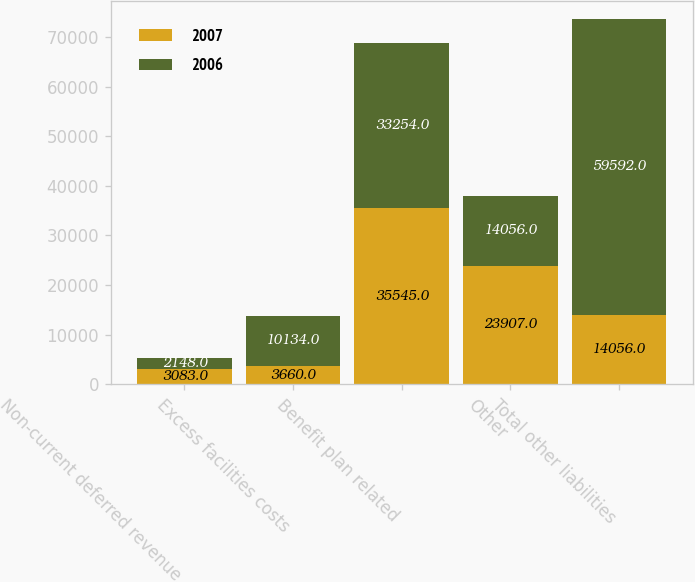Convert chart to OTSL. <chart><loc_0><loc_0><loc_500><loc_500><stacked_bar_chart><ecel><fcel>Non-current deferred revenue<fcel>Excess facilities costs<fcel>Benefit plan related<fcel>Other<fcel>Total other liabilities<nl><fcel>2007<fcel>3083<fcel>3660<fcel>35545<fcel>23907<fcel>14056<nl><fcel>2006<fcel>2148<fcel>10134<fcel>33254<fcel>14056<fcel>59592<nl></chart> 